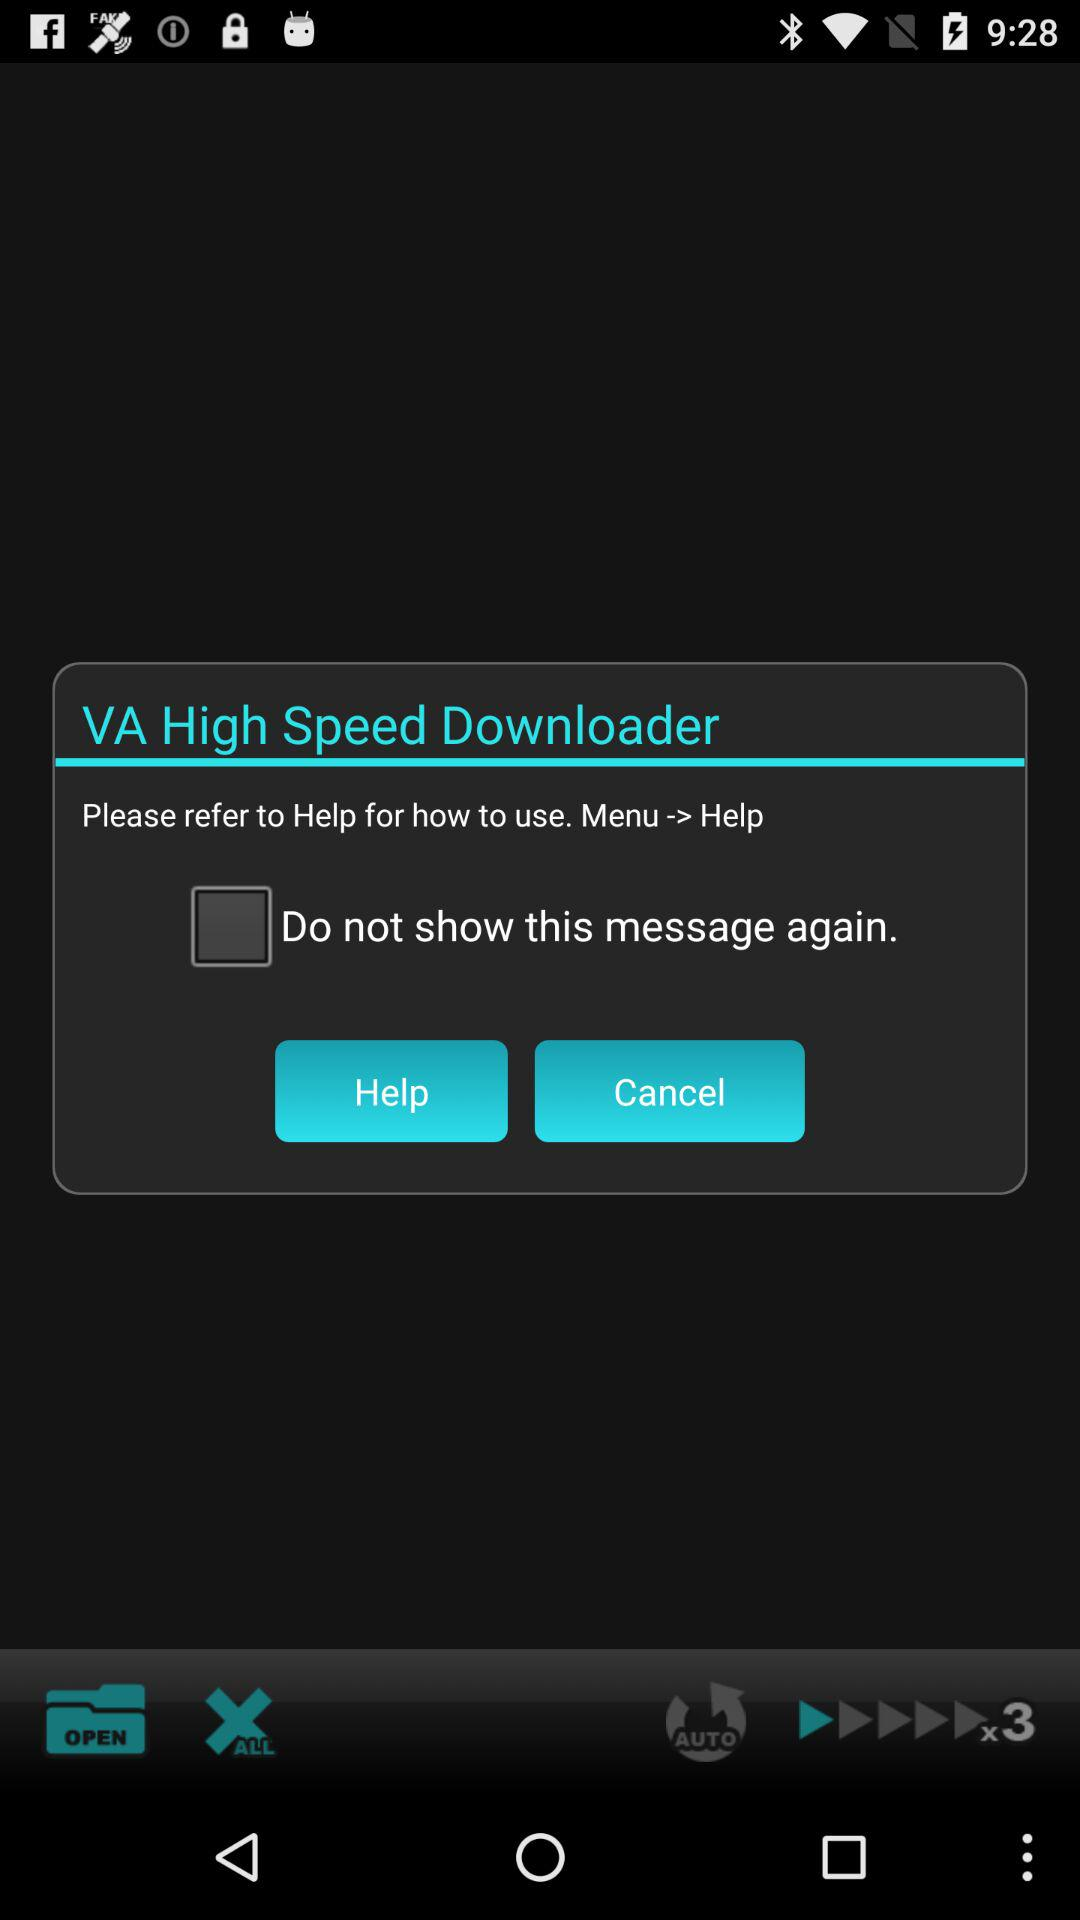What is the status of "Do not show this message again"? The status is "off". 